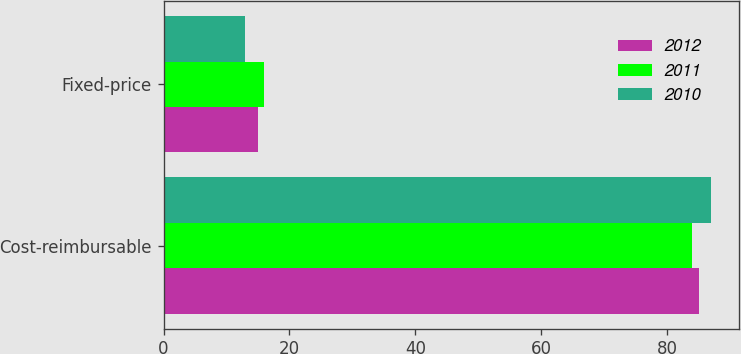<chart> <loc_0><loc_0><loc_500><loc_500><stacked_bar_chart><ecel><fcel>Cost-reimbursable<fcel>Fixed-price<nl><fcel>2012<fcel>85<fcel>15<nl><fcel>2011<fcel>84<fcel>16<nl><fcel>2010<fcel>87<fcel>13<nl></chart> 